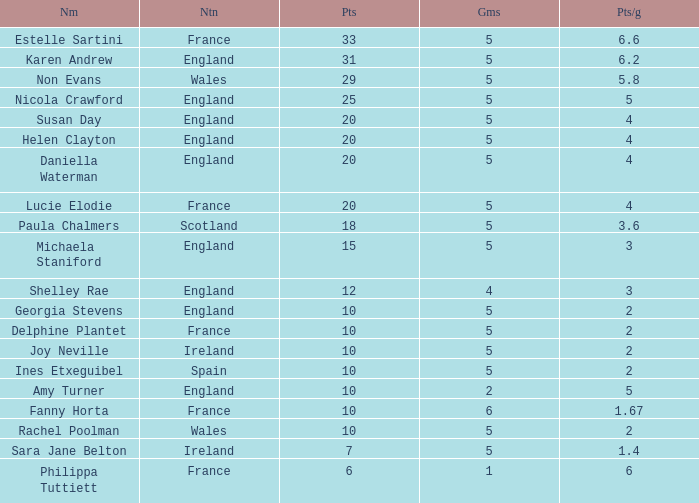Can you tell me the lowest Games that has the Pts/game larger than 1.4 and the Points of 20, and the Name of susan day? 5.0. 